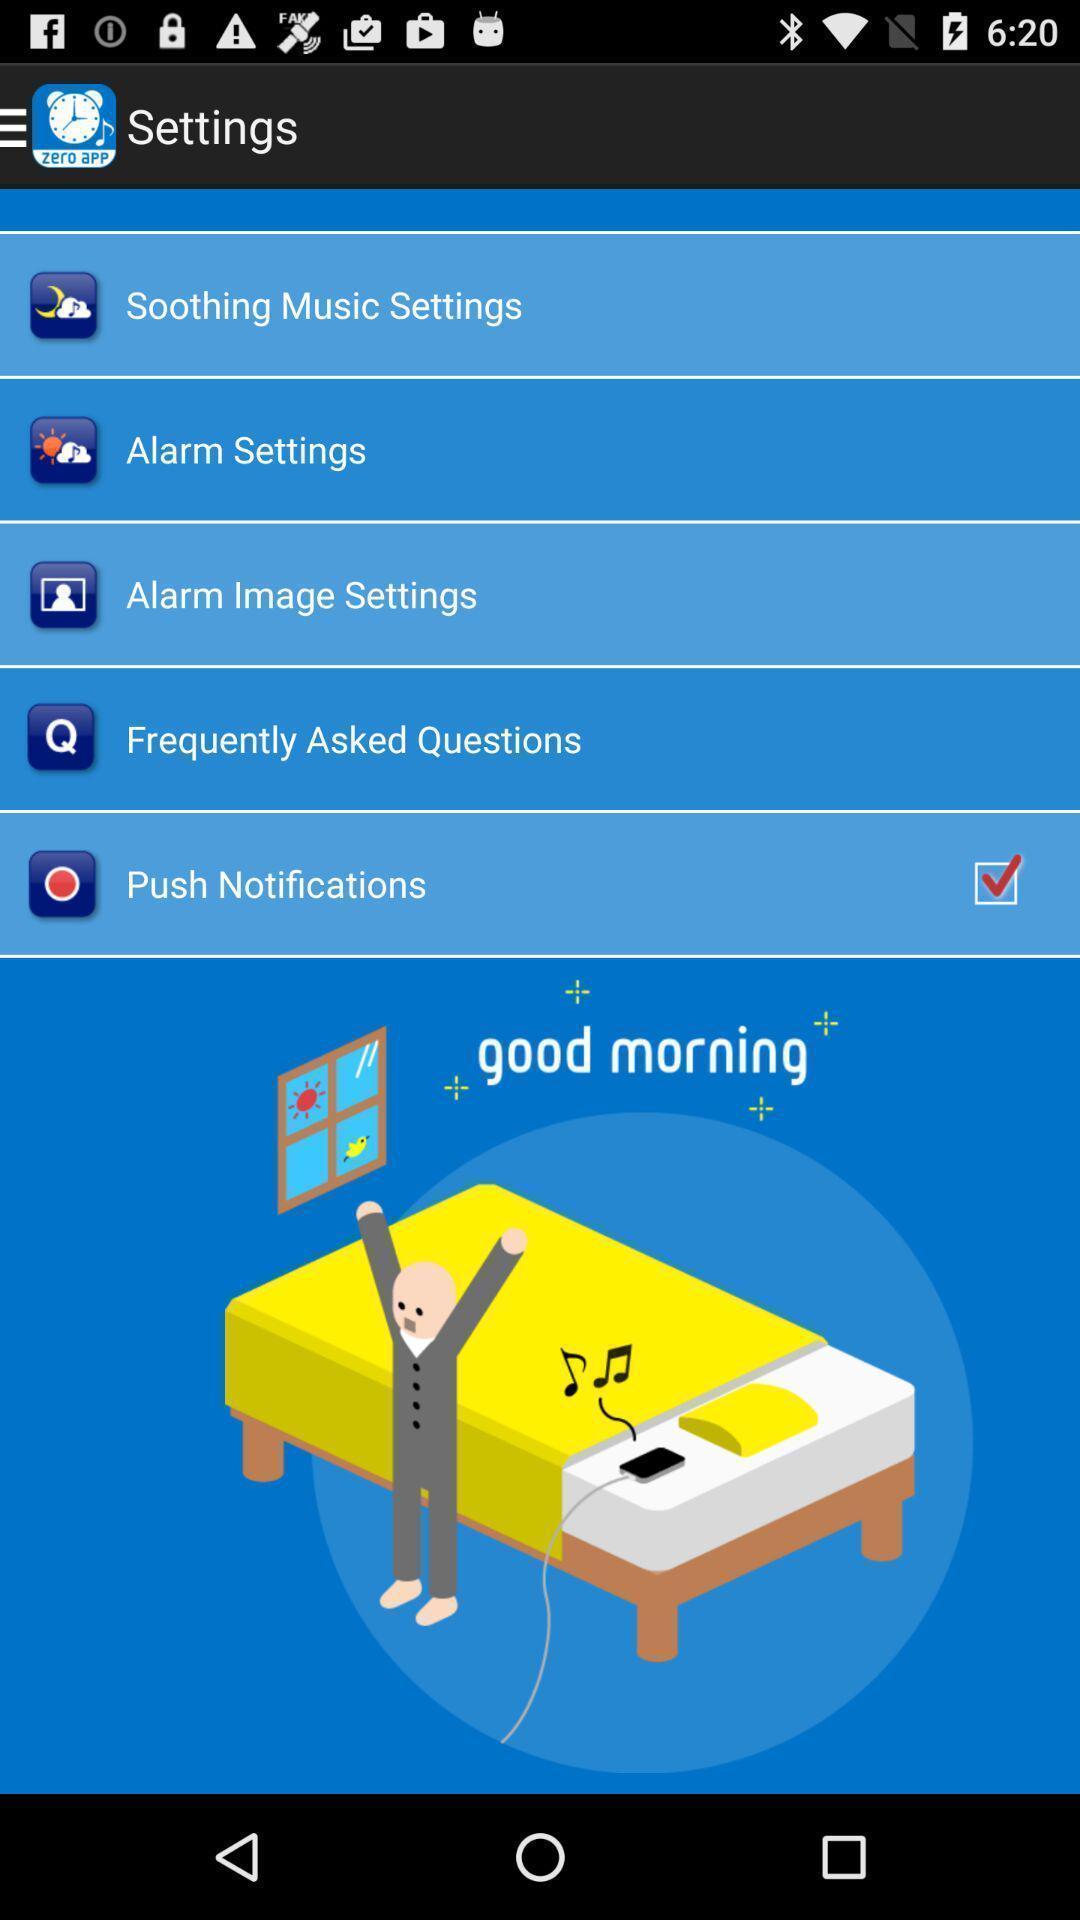Give me a narrative description of this picture. Screen showing settings page in an alarm application. 